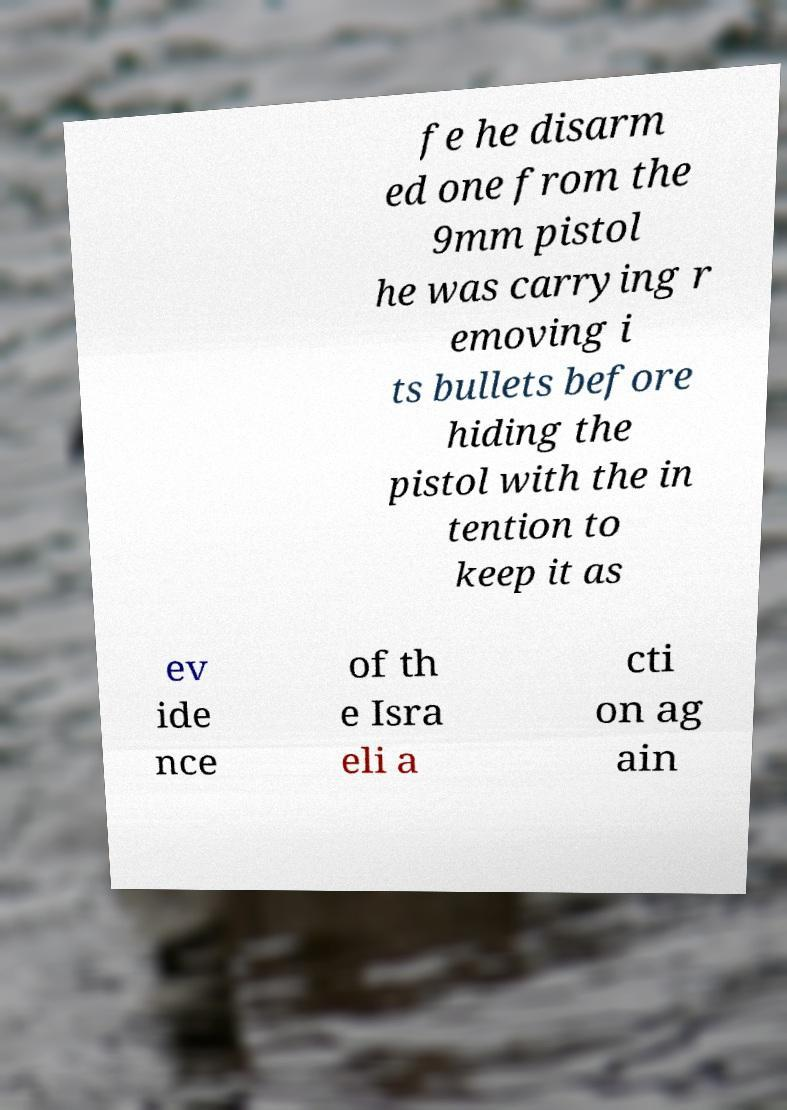For documentation purposes, I need the text within this image transcribed. Could you provide that? fe he disarm ed one from the 9mm pistol he was carrying r emoving i ts bullets before hiding the pistol with the in tention to keep it as ev ide nce of th e Isra eli a cti on ag ain 